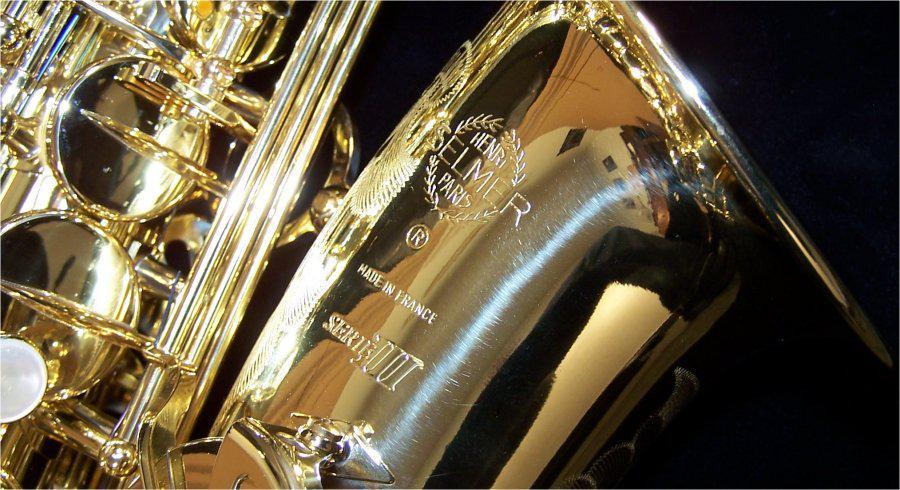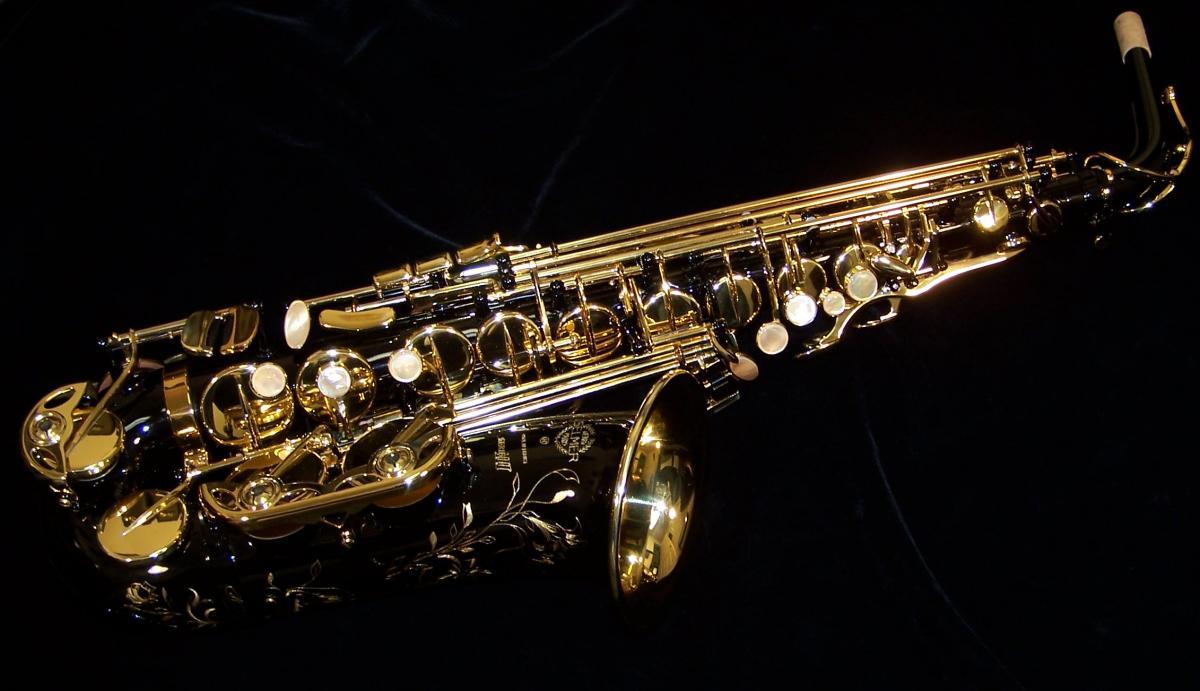The first image is the image on the left, the second image is the image on the right. Assess this claim about the two images: "The right image shows a saxophone displayed nearly horizontally, with its mouthpiece attached and facing upward.". Correct or not? Answer yes or no. Yes. 